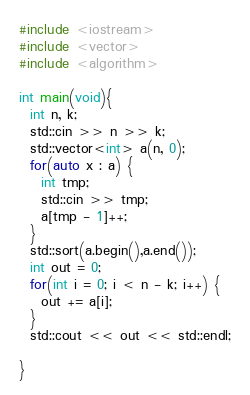Convert code to text. <code><loc_0><loc_0><loc_500><loc_500><_C_>#include <iostream>
#include <vector>
#include <algorithm>

int main(void){
  int n, k;
  std::cin >> n >> k;
  std::vector<int> a(n, 0);
  for(auto x : a) {
    int tmp;
    std::cin >> tmp;
    a[tmp - 1]++;
  }
  std::sort(a.begin(),a.end());
  int out = 0;
  for(int i = 0; i < n - k; i++) {
    out += a[i];
  }
  std::cout << out << std::endl;

}
</code> 